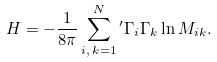<formula> <loc_0><loc_0><loc_500><loc_500>H = - \frac { 1 } { 8 \pi } \sum _ { i , \, k = 1 } ^ { N } { ^ { \prime } } \Gamma _ { i } \Gamma _ { k } \ln M _ { i k } .</formula> 